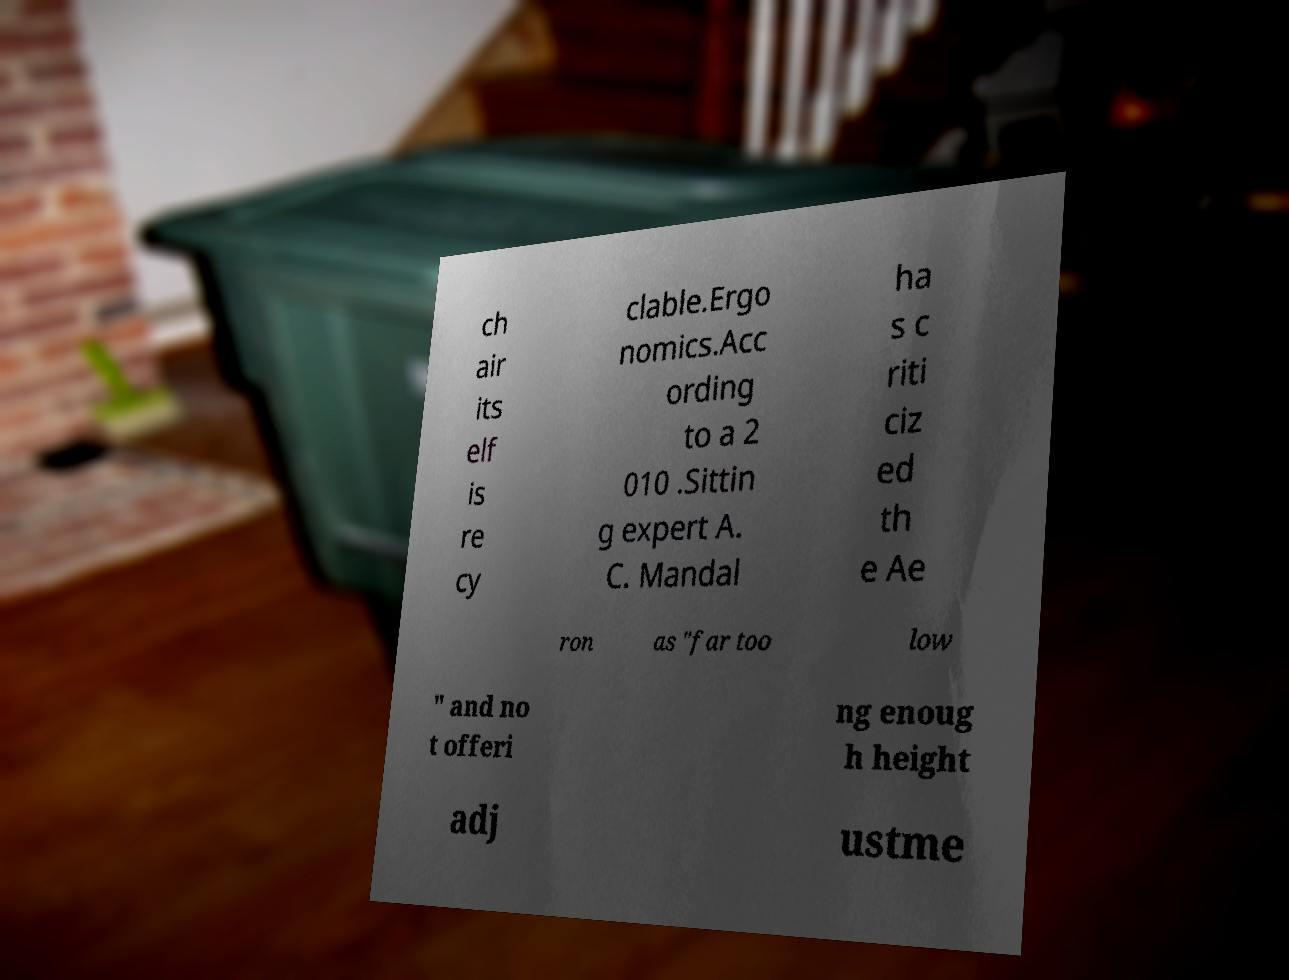I need the written content from this picture converted into text. Can you do that? ch air its elf is re cy clable.Ergo nomics.Acc ording to a 2 010 .Sittin g expert A. C. Mandal ha s c riti ciz ed th e Ae ron as "far too low " and no t offeri ng enoug h height adj ustme 